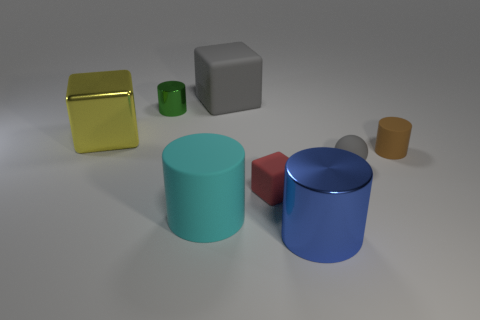Do the small gray ball and the small cylinder that is to the right of the green metal thing have the same material?
Offer a very short reply. Yes. There is a gray rubber object in front of the matte block that is behind the tiny gray ball; what is its shape?
Make the answer very short. Sphere. Is the size of the metal cylinder to the right of the cyan object the same as the big yellow shiny thing?
Keep it short and to the point. Yes. What number of other things are the same shape as the large gray matte object?
Make the answer very short. 2. There is a big cube on the right side of the large yellow shiny thing; is its color the same as the tiny rubber cylinder?
Offer a terse response. No. Is there a metal cylinder of the same color as the large matte cylinder?
Provide a succinct answer. No. What number of small red rubber objects are on the left side of the big blue thing?
Your answer should be compact. 1. How many other objects are there of the same size as the green thing?
Offer a very short reply. 3. Are the small cylinder that is to the right of the small gray rubber sphere and the large cylinder that is on the left side of the small matte block made of the same material?
Offer a very short reply. Yes. What color is the metal cylinder that is the same size as the rubber ball?
Your answer should be very brief. Green. 